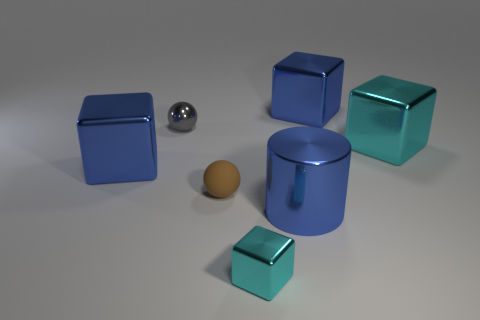Add 1 large blue things. How many objects exist? 8 Subtract all cubes. How many objects are left? 3 Add 5 big blue metallic cylinders. How many big blue metallic cylinders are left? 6 Add 3 small cyan things. How many small cyan things exist? 4 Subtract 0 gray cubes. How many objects are left? 7 Subtract all big brown blocks. Subtract all gray things. How many objects are left? 6 